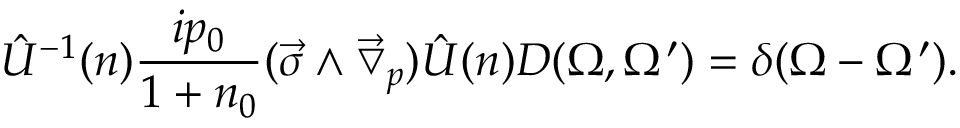Convert formula to latex. <formula><loc_0><loc_0><loc_500><loc_500>\hat { U } ^ { - 1 } ( n ) \frac { i p _ { 0 } } { 1 + n _ { 0 } } ( \vec { \sigma } \wedge \vec { \bigtriangledown } _ { p } ) \hat { U } ( n ) D ( \Omega , \Omega ^ { \prime } ) = \delta ( \Omega - \Omega ^ { \prime } ) .</formula> 